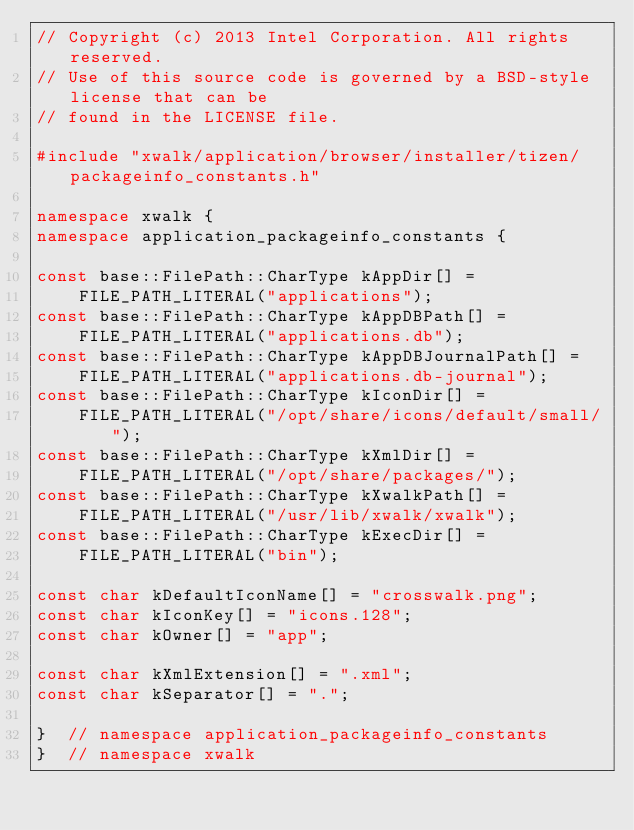<code> <loc_0><loc_0><loc_500><loc_500><_C++_>// Copyright (c) 2013 Intel Corporation. All rights reserved.
// Use of this source code is governed by a BSD-style license that can be
// found in the LICENSE file.

#include "xwalk/application/browser/installer/tizen/packageinfo_constants.h"

namespace xwalk {
namespace application_packageinfo_constants {

const base::FilePath::CharType kAppDir[] =
    FILE_PATH_LITERAL("applications");
const base::FilePath::CharType kAppDBPath[] =
    FILE_PATH_LITERAL("applications.db");
const base::FilePath::CharType kAppDBJournalPath[] =
    FILE_PATH_LITERAL("applications.db-journal");
const base::FilePath::CharType kIconDir[] =
    FILE_PATH_LITERAL("/opt/share/icons/default/small/");
const base::FilePath::CharType kXmlDir[] =
    FILE_PATH_LITERAL("/opt/share/packages/");
const base::FilePath::CharType kXwalkPath[] =
    FILE_PATH_LITERAL("/usr/lib/xwalk/xwalk");
const base::FilePath::CharType kExecDir[] =
    FILE_PATH_LITERAL("bin");

const char kDefaultIconName[] = "crosswalk.png";
const char kIconKey[] = "icons.128";
const char kOwner[] = "app";

const char kXmlExtension[] = ".xml";
const char kSeparator[] = ".";

}  // namespace application_packageinfo_constants
}  // namespace xwalk
</code> 